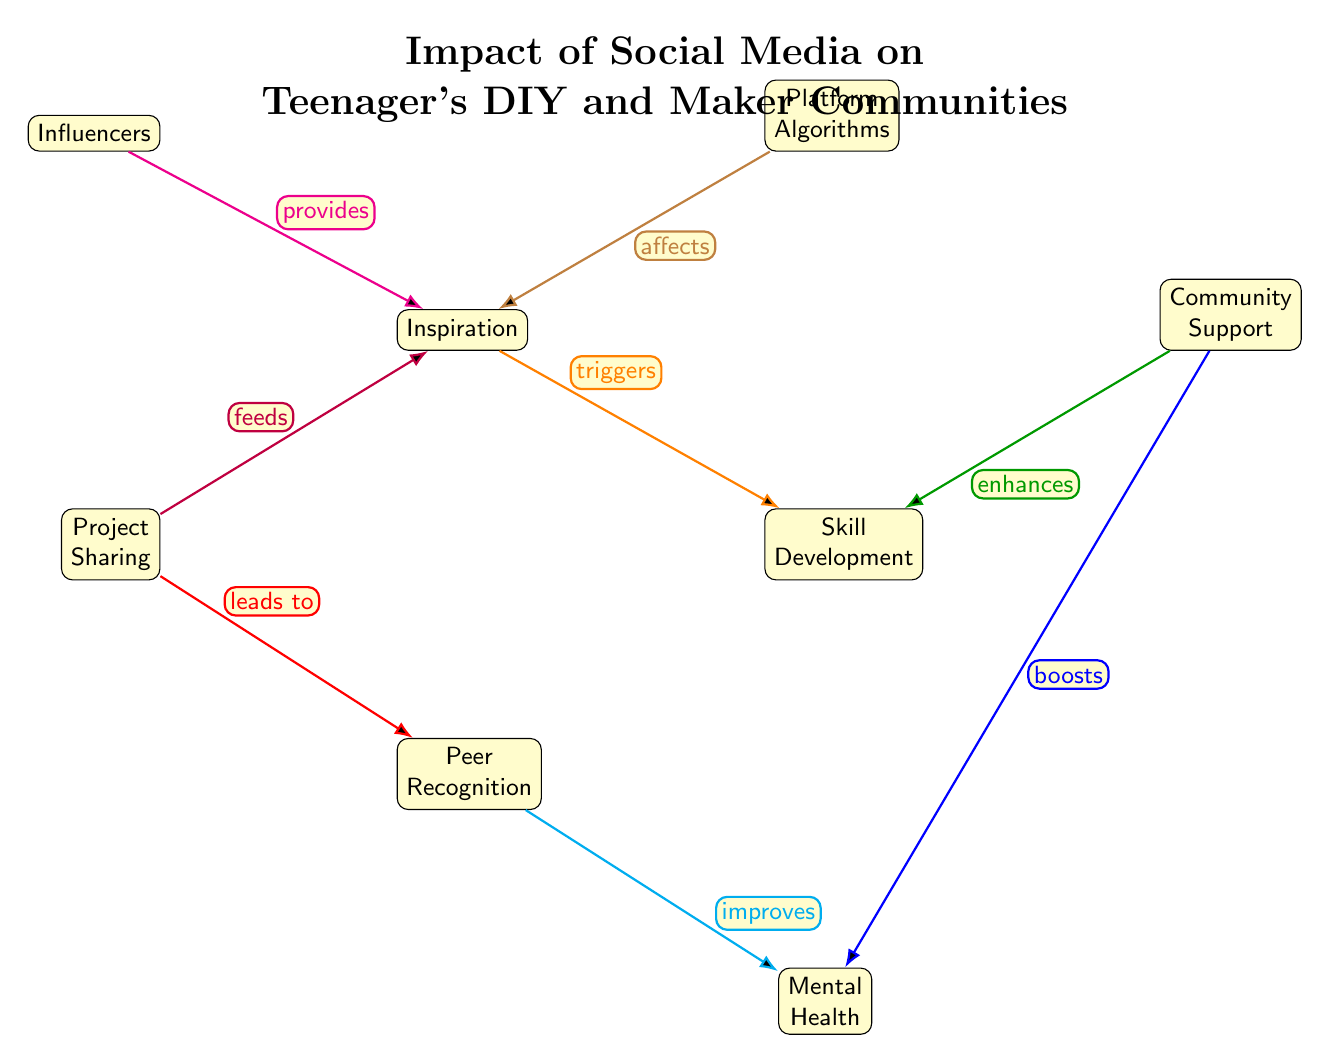What is the primary title of the diagram? The title of the diagram is given at the top, stating the concern of the visual representation. It is "Impact of Social Media on Teenager's DIY and Maker Communities."
Answer: Impact of Social Media on Teenager's DIY and Maker Communities How many nodes are present in the diagram? By counting each distinct labeled element in the diagram, we can identify the total number of nodes represented. There are eight nodes in total.
Answer: 8 What relationship do Project Sharing and Inspiration have? The connection from Project Sharing to Inspiration is indicated with the label "feeds," showing that sharing projects contributes to generating inspiration.
Answer: feeds Which node enhances Skill Development? Examining the edges, the Community Support node is connected to Skill Development and is labeled "enhances," indicating that it improves the skill development process.
Answer: Community Support What is the effect of Peer Recognition on Mental Health? The relationship between Peer Recognition and Mental Health is highlighted by an edge labeled "improves," illustrating that receiving recognition from peers positively impacts mental health.
Answer: improves What does the node Influencers provide? The label on the edge connecting Influencers to Inspiration shows that the influencers are a source for inspiration among teenagers in DIY and maker communities.
Answer: provides What aspect do Platform Algorithms affect? The arrow from Platform Algorithms indicates a direct impact on Inspiration, denoted by the word "affects," highlighting their role in shaping what inspires teenagers.
Answer: affects Which node is related to Community Support? Community Support has two connections directed towards Skill Development (enhances) and Mental Health (boosts), showing its significance in both areas. The related node is Skill Development.
Answer: Skill Development What role does Inspiration play in relation to Skill Development? The edge labeled "triggers" indicates that Inspiration initiates or catalyzes the process of Skill Development, highlighting its foundational role.
Answer: triggers 